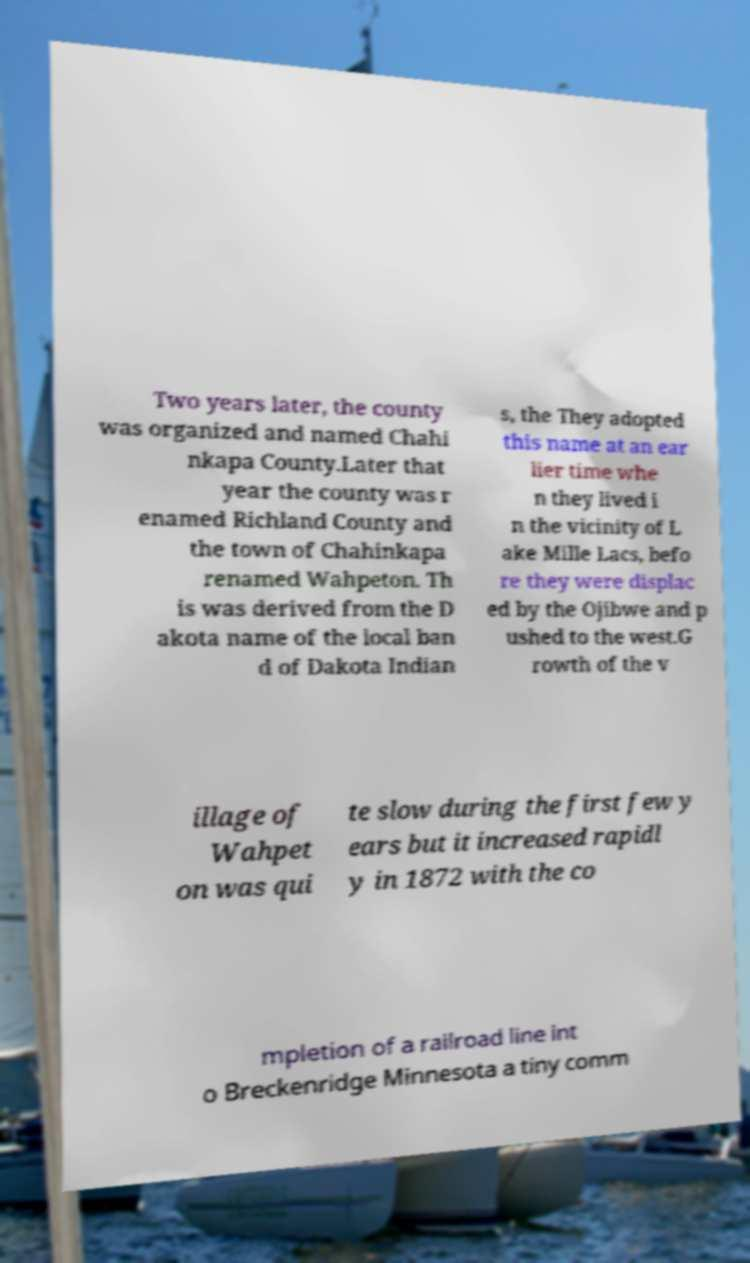Please read and relay the text visible in this image. What does it say? Two years later, the county was organized and named Chahi nkapa County.Later that year the county was r enamed Richland County and the town of Chahinkapa renamed Wahpeton. Th is was derived from the D akota name of the local ban d of Dakota Indian s, the They adopted this name at an ear lier time whe n they lived i n the vicinity of L ake Mille Lacs, befo re they were displac ed by the Ojibwe and p ushed to the west.G rowth of the v illage of Wahpet on was qui te slow during the first few y ears but it increased rapidl y in 1872 with the co mpletion of a railroad line int o Breckenridge Minnesota a tiny comm 